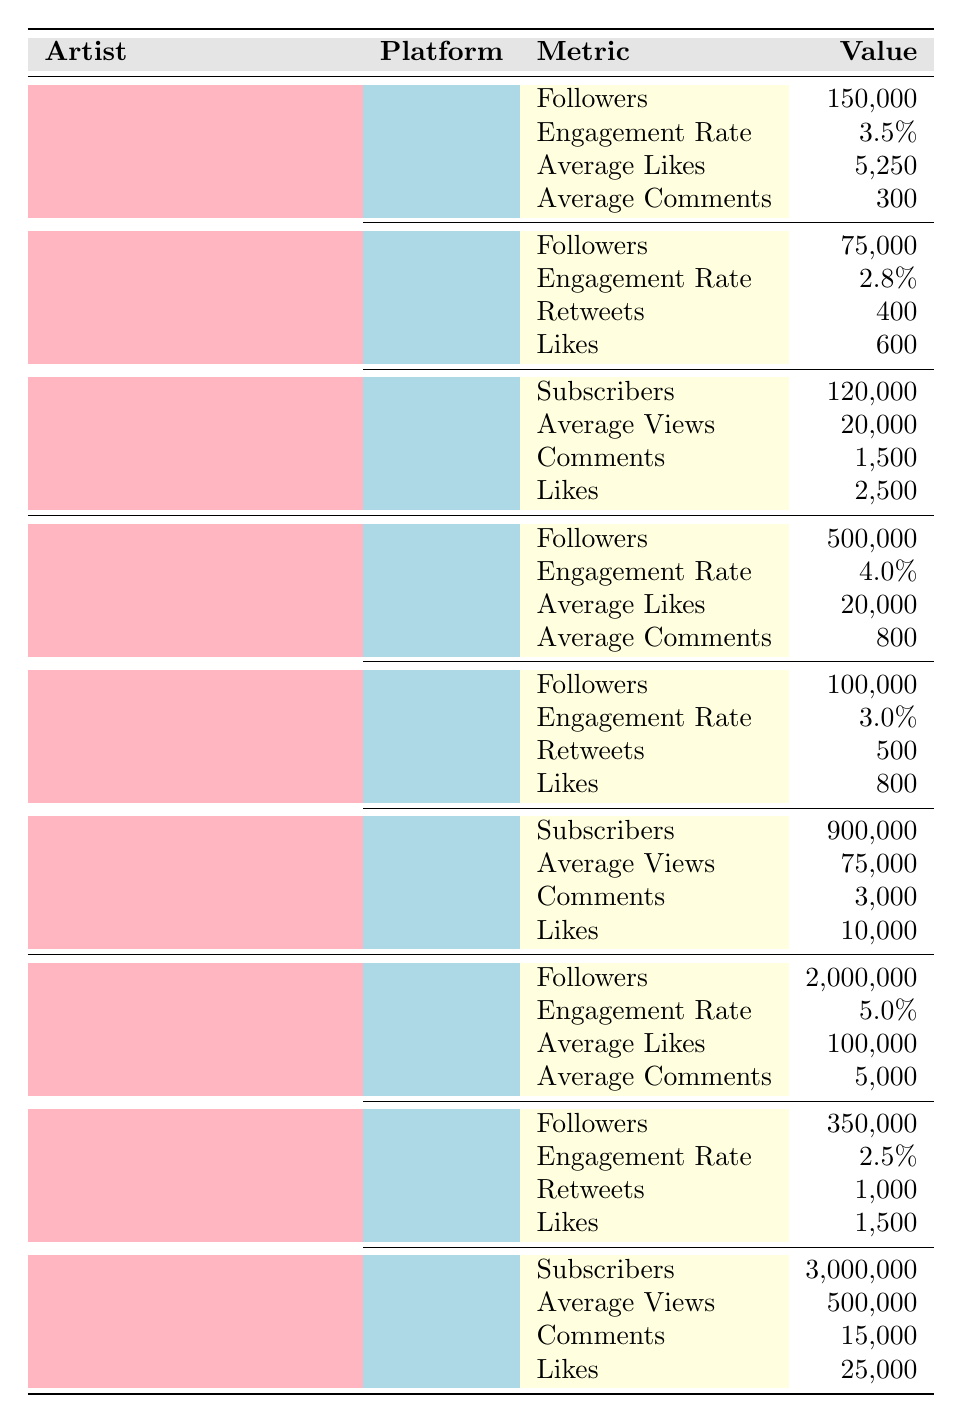What is the total number of Instagram followers for all three artists? Elle Limebear has 150,000 followers, Tasha Cobbs Leonard has 500,000 followers, and Lauren Daigle has 2,000,000 followers. Adding these numbers together: 150,000 + 500,000 + 2,000,000 = 2,650,000.
Answer: 2,650,000 Which artist has the highest engagement rate on Instagram? Elle Limebear's engagement rate is 3.5%, Tasha Cobbs Leonard's is 4.0%, and Lauren Daigle's is 5.0%. Comparing these rates, Lauren Daigle has the highest at 5.0%.
Answer: Lauren Daigle How many more average likes does Tasha Cobbs Leonard have on Instagram compared to Elle Limebear? Tasha Cobbs Leonard has 20,000 average likes, while Elle Limebear has 5,250. The difference is 20,000 - 5,250 = 14,750.
Answer: 14,750 Does Lauren Daigle have more YouTube subscribers than Tasha Cobbs Leonard? Lauren Daigle has 3,000,000 subscribers, and Tasha Cobbs Leonard has 900,000 subscribers. Since 3,000,000 is greater than 900,000, the answer is yes.
Answer: Yes What is the average number of likes across all platforms for Elle Limebear? On Instagram, Elle Limebear has 5,250 likes, on Twitter, she has 600 likes, and on YouTube, she has 2,500 likes. To find the average: (5,250 + 600 + 2,500) / 3 = 8,350 / 3 = 2,783.33, rounded to 2,783.
Answer: 2,783 Which platform provides the most engagement for Lauren Daigle? Analyzing engagement rates: Instagram is at 5.0%, Twitter at 2.5%, and YouTube does not have an engagement rate listed. Since 5.0% is the highest, Instagram provides the most engagement.
Answer: Instagram How many more comments does Tasha Cobbs Leonard have on YouTube compared to Elle Limebear? Tasha Cobbs Leonard has 3,000 comments on YouTube, and Elle Limebear has 1,500. The difference is 3,000 - 1,500 = 1,500.
Answer: 1,500 What is the combined engagement rate for Tasha Cobbs Leonard on Instagram and Twitter? Tasha Cobbs Leonard's engagement rate on Instagram is 4.0% and on Twitter is 3.0%. To find the combined rate, we calculate the average: (4.0 + 3.0) / 2 = 3.5%.
Answer: 3.5% Is it true that Tasha Cobbs Leonard has more Twitter followers than Elle Limebear? Tasha Cobbs Leonard has 100,000 Twitter followers, while Elle Limebear has 75,000 Twitter followers. Since 100,000 is greater than 75,000, the answer is yes.
Answer: Yes 